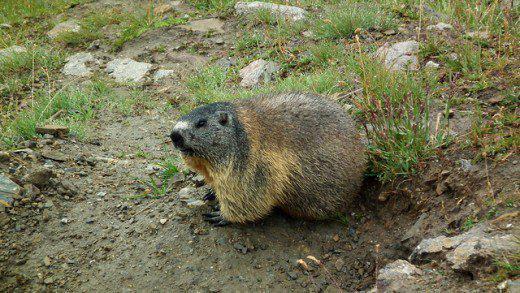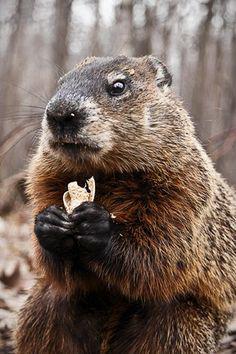The first image is the image on the left, the second image is the image on the right. Given the left and right images, does the statement "there is a gopher sitting with food in its hands" hold true? Answer yes or no. Yes. The first image is the image on the left, the second image is the image on the right. Evaluate the accuracy of this statement regarding the images: "There are 3 prairie dogs with at least 2 of them standing upright.". Is it true? Answer yes or no. No. 